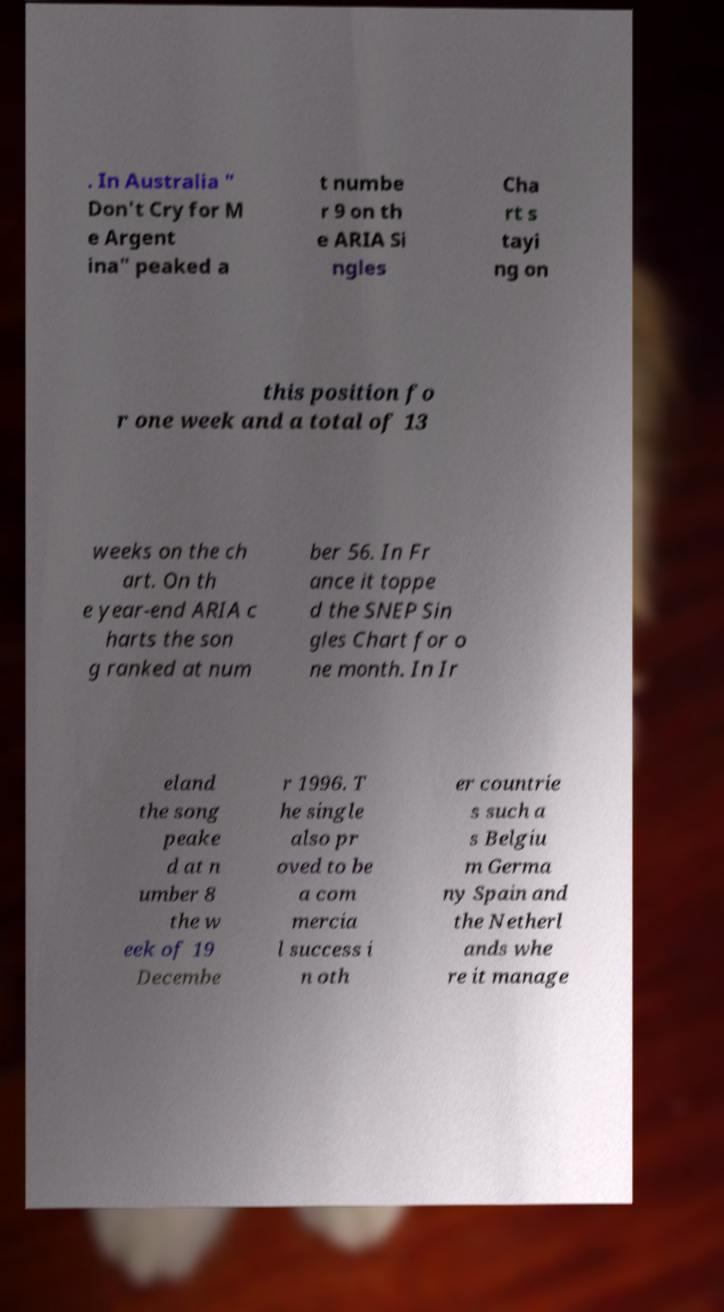What messages or text are displayed in this image? I need them in a readable, typed format. . In Australia " Don't Cry for M e Argent ina" peaked a t numbe r 9 on th e ARIA Si ngles Cha rt s tayi ng on this position fo r one week and a total of 13 weeks on the ch art. On th e year-end ARIA c harts the son g ranked at num ber 56. In Fr ance it toppe d the SNEP Sin gles Chart for o ne month. In Ir eland the song peake d at n umber 8 the w eek of 19 Decembe r 1996. T he single also pr oved to be a com mercia l success i n oth er countrie s such a s Belgiu m Germa ny Spain and the Netherl ands whe re it manage 